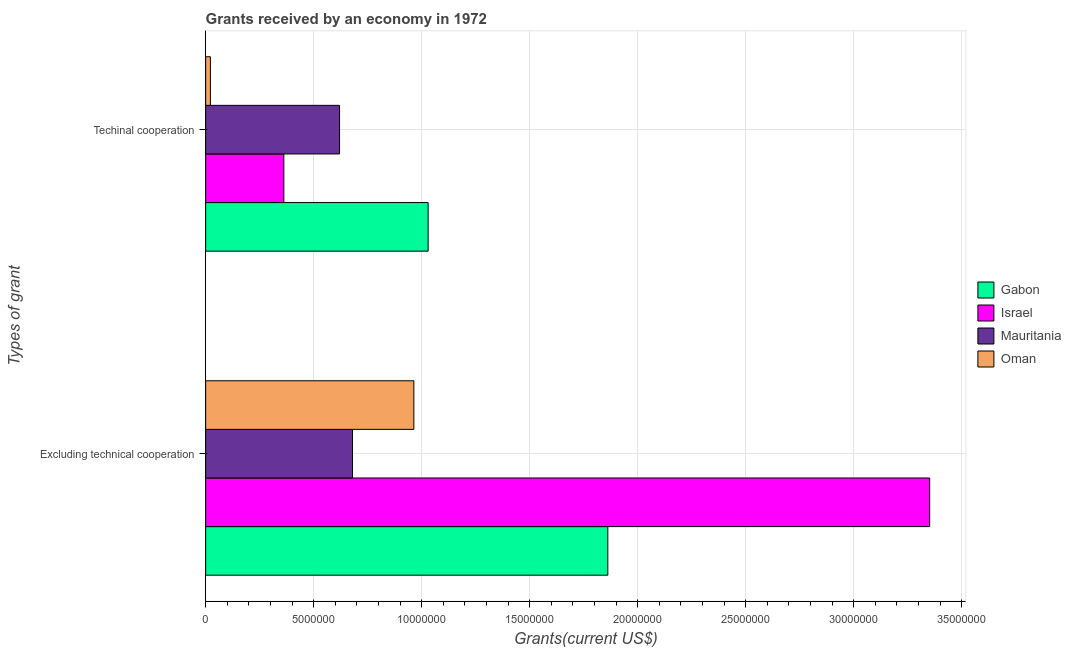How many different coloured bars are there?
Provide a short and direct response. 4. Are the number of bars per tick equal to the number of legend labels?
Your answer should be very brief. Yes. Are the number of bars on each tick of the Y-axis equal?
Offer a terse response. Yes. How many bars are there on the 2nd tick from the top?
Your answer should be compact. 4. What is the label of the 2nd group of bars from the top?
Your answer should be very brief. Excluding technical cooperation. What is the amount of grants received(including technical cooperation) in Israel?
Provide a short and direct response. 3.62e+06. Across all countries, what is the maximum amount of grants received(including technical cooperation)?
Provide a succinct answer. 1.03e+07. Across all countries, what is the minimum amount of grants received(including technical cooperation)?
Your response must be concise. 2.20e+05. In which country was the amount of grants received(including technical cooperation) maximum?
Your response must be concise. Gabon. In which country was the amount of grants received(including technical cooperation) minimum?
Your answer should be very brief. Oman. What is the total amount of grants received(including technical cooperation) in the graph?
Provide a short and direct response. 2.03e+07. What is the difference between the amount of grants received(including technical cooperation) in Israel and that in Mauritania?
Keep it short and to the point. -2.58e+06. What is the difference between the amount of grants received(including technical cooperation) in Oman and the amount of grants received(excluding technical cooperation) in Mauritania?
Provide a short and direct response. -6.58e+06. What is the average amount of grants received(excluding technical cooperation) per country?
Your answer should be compact. 1.71e+07. What is the difference between the amount of grants received(including technical cooperation) and amount of grants received(excluding technical cooperation) in Israel?
Provide a succinct answer. -2.99e+07. In how many countries, is the amount of grants received(including technical cooperation) greater than 31000000 US$?
Your answer should be compact. 0. What is the ratio of the amount of grants received(including technical cooperation) in Oman to that in Israel?
Make the answer very short. 0.06. In how many countries, is the amount of grants received(excluding technical cooperation) greater than the average amount of grants received(excluding technical cooperation) taken over all countries?
Offer a very short reply. 2. What does the 1st bar from the top in Techinal cooperation represents?
Your response must be concise. Oman. What does the 1st bar from the bottom in Techinal cooperation represents?
Give a very brief answer. Gabon. How many bars are there?
Provide a succinct answer. 8. How many countries are there in the graph?
Your answer should be compact. 4. What is the difference between two consecutive major ticks on the X-axis?
Keep it short and to the point. 5.00e+06. Does the graph contain grids?
Provide a succinct answer. Yes. Where does the legend appear in the graph?
Your answer should be very brief. Center right. What is the title of the graph?
Provide a succinct answer. Grants received by an economy in 1972. Does "High income: OECD" appear as one of the legend labels in the graph?
Ensure brevity in your answer.  No. What is the label or title of the X-axis?
Ensure brevity in your answer.  Grants(current US$). What is the label or title of the Y-axis?
Your answer should be very brief. Types of grant. What is the Grants(current US$) in Gabon in Excluding technical cooperation?
Offer a very short reply. 1.86e+07. What is the Grants(current US$) in Israel in Excluding technical cooperation?
Keep it short and to the point. 3.35e+07. What is the Grants(current US$) in Mauritania in Excluding technical cooperation?
Offer a terse response. 6.80e+06. What is the Grants(current US$) of Oman in Excluding technical cooperation?
Provide a succinct answer. 9.64e+06. What is the Grants(current US$) of Gabon in Techinal cooperation?
Offer a terse response. 1.03e+07. What is the Grants(current US$) in Israel in Techinal cooperation?
Give a very brief answer. 3.62e+06. What is the Grants(current US$) of Mauritania in Techinal cooperation?
Ensure brevity in your answer.  6.20e+06. What is the Grants(current US$) in Oman in Techinal cooperation?
Your response must be concise. 2.20e+05. Across all Types of grant, what is the maximum Grants(current US$) in Gabon?
Offer a very short reply. 1.86e+07. Across all Types of grant, what is the maximum Grants(current US$) in Israel?
Your response must be concise. 3.35e+07. Across all Types of grant, what is the maximum Grants(current US$) in Mauritania?
Provide a succinct answer. 6.80e+06. Across all Types of grant, what is the maximum Grants(current US$) in Oman?
Make the answer very short. 9.64e+06. Across all Types of grant, what is the minimum Grants(current US$) in Gabon?
Provide a succinct answer. 1.03e+07. Across all Types of grant, what is the minimum Grants(current US$) of Israel?
Ensure brevity in your answer.  3.62e+06. Across all Types of grant, what is the minimum Grants(current US$) in Mauritania?
Your response must be concise. 6.20e+06. What is the total Grants(current US$) in Gabon in the graph?
Keep it short and to the point. 2.89e+07. What is the total Grants(current US$) in Israel in the graph?
Your answer should be compact. 3.71e+07. What is the total Grants(current US$) of Mauritania in the graph?
Provide a succinct answer. 1.30e+07. What is the total Grants(current US$) of Oman in the graph?
Provide a succinct answer. 9.86e+06. What is the difference between the Grants(current US$) of Gabon in Excluding technical cooperation and that in Techinal cooperation?
Give a very brief answer. 8.32e+06. What is the difference between the Grants(current US$) of Israel in Excluding technical cooperation and that in Techinal cooperation?
Offer a terse response. 2.99e+07. What is the difference between the Grants(current US$) in Mauritania in Excluding technical cooperation and that in Techinal cooperation?
Offer a terse response. 6.00e+05. What is the difference between the Grants(current US$) in Oman in Excluding technical cooperation and that in Techinal cooperation?
Give a very brief answer. 9.42e+06. What is the difference between the Grants(current US$) of Gabon in Excluding technical cooperation and the Grants(current US$) of Israel in Techinal cooperation?
Keep it short and to the point. 1.50e+07. What is the difference between the Grants(current US$) of Gabon in Excluding technical cooperation and the Grants(current US$) of Mauritania in Techinal cooperation?
Provide a short and direct response. 1.24e+07. What is the difference between the Grants(current US$) in Gabon in Excluding technical cooperation and the Grants(current US$) in Oman in Techinal cooperation?
Provide a short and direct response. 1.84e+07. What is the difference between the Grants(current US$) of Israel in Excluding technical cooperation and the Grants(current US$) of Mauritania in Techinal cooperation?
Provide a succinct answer. 2.73e+07. What is the difference between the Grants(current US$) in Israel in Excluding technical cooperation and the Grants(current US$) in Oman in Techinal cooperation?
Provide a short and direct response. 3.33e+07. What is the difference between the Grants(current US$) in Mauritania in Excluding technical cooperation and the Grants(current US$) in Oman in Techinal cooperation?
Give a very brief answer. 6.58e+06. What is the average Grants(current US$) of Gabon per Types of grant?
Your answer should be very brief. 1.45e+07. What is the average Grants(current US$) of Israel per Types of grant?
Your response must be concise. 1.86e+07. What is the average Grants(current US$) of Mauritania per Types of grant?
Offer a very short reply. 6.50e+06. What is the average Grants(current US$) of Oman per Types of grant?
Ensure brevity in your answer.  4.93e+06. What is the difference between the Grants(current US$) in Gabon and Grants(current US$) in Israel in Excluding technical cooperation?
Ensure brevity in your answer.  -1.49e+07. What is the difference between the Grants(current US$) in Gabon and Grants(current US$) in Mauritania in Excluding technical cooperation?
Keep it short and to the point. 1.18e+07. What is the difference between the Grants(current US$) in Gabon and Grants(current US$) in Oman in Excluding technical cooperation?
Your answer should be very brief. 8.98e+06. What is the difference between the Grants(current US$) in Israel and Grants(current US$) in Mauritania in Excluding technical cooperation?
Provide a succinct answer. 2.67e+07. What is the difference between the Grants(current US$) of Israel and Grants(current US$) of Oman in Excluding technical cooperation?
Keep it short and to the point. 2.39e+07. What is the difference between the Grants(current US$) in Mauritania and Grants(current US$) in Oman in Excluding technical cooperation?
Provide a short and direct response. -2.84e+06. What is the difference between the Grants(current US$) in Gabon and Grants(current US$) in Israel in Techinal cooperation?
Provide a succinct answer. 6.68e+06. What is the difference between the Grants(current US$) of Gabon and Grants(current US$) of Mauritania in Techinal cooperation?
Keep it short and to the point. 4.10e+06. What is the difference between the Grants(current US$) of Gabon and Grants(current US$) of Oman in Techinal cooperation?
Ensure brevity in your answer.  1.01e+07. What is the difference between the Grants(current US$) of Israel and Grants(current US$) of Mauritania in Techinal cooperation?
Make the answer very short. -2.58e+06. What is the difference between the Grants(current US$) in Israel and Grants(current US$) in Oman in Techinal cooperation?
Keep it short and to the point. 3.40e+06. What is the difference between the Grants(current US$) in Mauritania and Grants(current US$) in Oman in Techinal cooperation?
Your answer should be compact. 5.98e+06. What is the ratio of the Grants(current US$) in Gabon in Excluding technical cooperation to that in Techinal cooperation?
Your answer should be very brief. 1.81. What is the ratio of the Grants(current US$) in Israel in Excluding technical cooperation to that in Techinal cooperation?
Your answer should be compact. 9.26. What is the ratio of the Grants(current US$) in Mauritania in Excluding technical cooperation to that in Techinal cooperation?
Offer a very short reply. 1.1. What is the ratio of the Grants(current US$) in Oman in Excluding technical cooperation to that in Techinal cooperation?
Your answer should be very brief. 43.82. What is the difference between the highest and the second highest Grants(current US$) in Gabon?
Your response must be concise. 8.32e+06. What is the difference between the highest and the second highest Grants(current US$) of Israel?
Your answer should be compact. 2.99e+07. What is the difference between the highest and the second highest Grants(current US$) in Mauritania?
Keep it short and to the point. 6.00e+05. What is the difference between the highest and the second highest Grants(current US$) of Oman?
Offer a very short reply. 9.42e+06. What is the difference between the highest and the lowest Grants(current US$) of Gabon?
Keep it short and to the point. 8.32e+06. What is the difference between the highest and the lowest Grants(current US$) in Israel?
Give a very brief answer. 2.99e+07. What is the difference between the highest and the lowest Grants(current US$) in Mauritania?
Give a very brief answer. 6.00e+05. What is the difference between the highest and the lowest Grants(current US$) of Oman?
Offer a very short reply. 9.42e+06. 